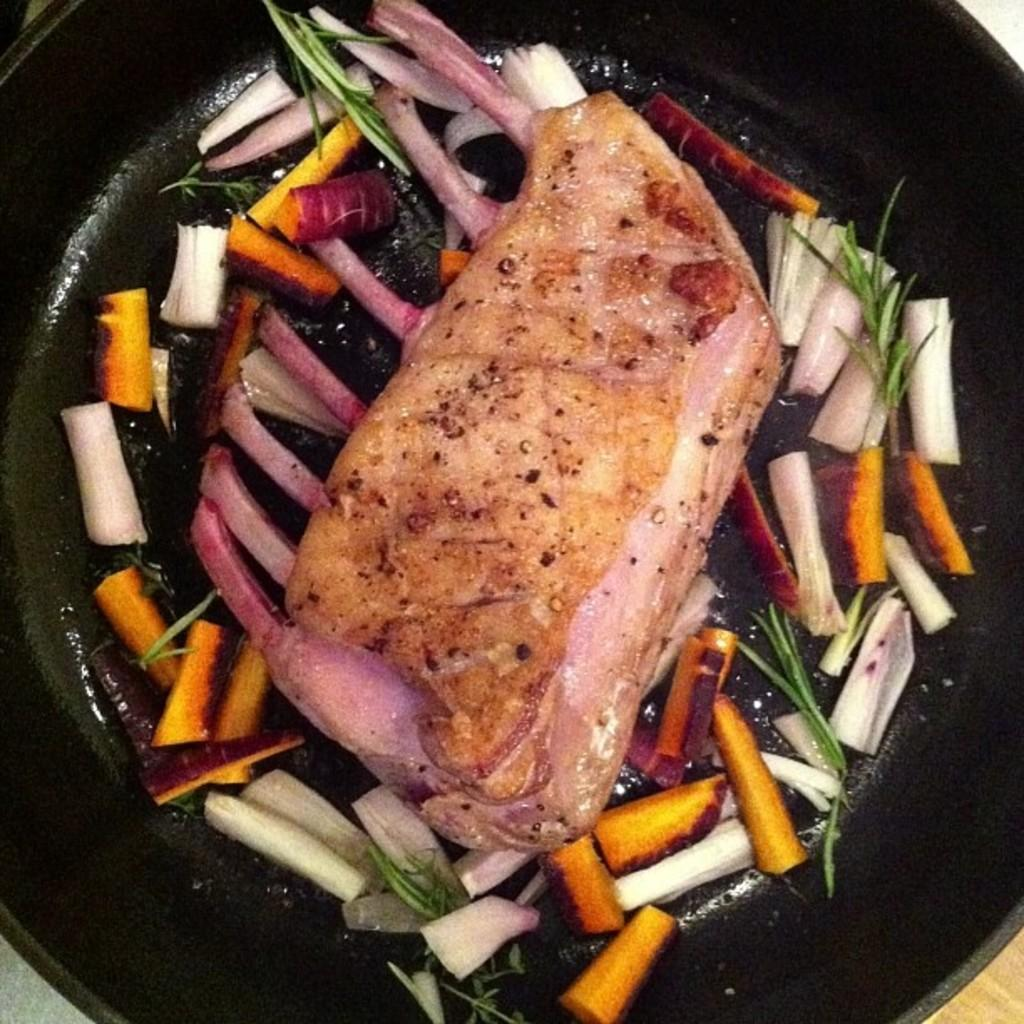What type of food items can be seen in the image? There are food items in the image, but their specific type is not mentioned. How are the food items arranged or placed in the image? The food items are in a pan. What arithmetic problem is being solved by the food items in the image? The food items in the image are not solving any arithmetic problem; they are simply arranged in a pan. What time of day is depicted in the image? The time of day is not mentioned or depicted in the image. 